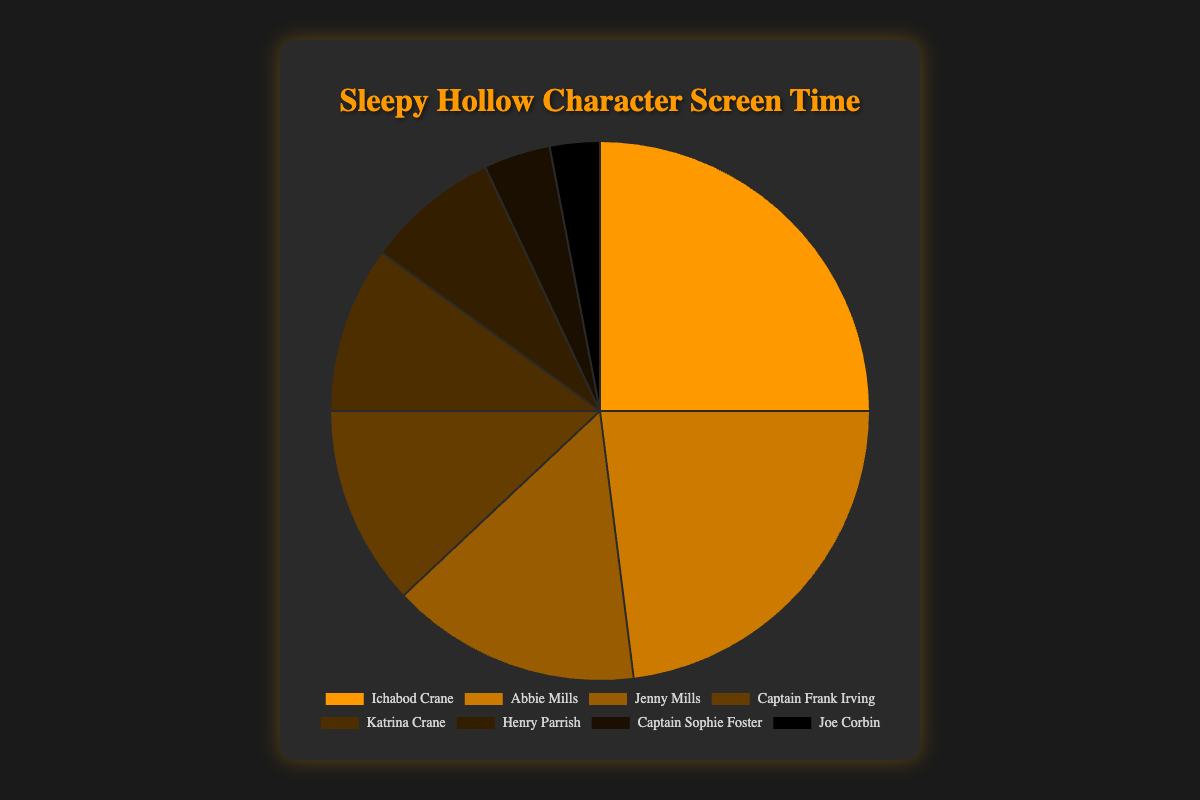Which character has the highest percentage of screen time? Ichabod Crane has the highest screen time percentage. By looking at the pie chart, Crane's segment is the largest, corresponding to 25%.
Answer: Ichabod Crane Compare the screen time percentages of Abbie Mills and Jenny Mills. Who has more and by how much? Abbie Mills has a 23% screen time percentage, while Jenny Mills has 15%. The difference is 23% - 15% = 8%.
Answer: Abbie Mills by 8% What is the combined screen time percentage of Captain Frank Irving, Katrina Crane, and Henry Parrish? Sum of screen time percentages of Captain Frank Irving (12%), Katrina Crane (10%), and Henry Parrish (8%) gives 12% + 10% + 8% = 30%.
Answer: 30% Which character has the least screen time percentage, and what is the percentage? Joe Corbin has the least screen time percentage, shown by the smallest segment on the pie chart at 3%.
Answer: Joe Corbin, 3% How does Ichabod Crane's screen time compare to the combined screen time of Captain Sophie Foster and Joe Corbin? Ichabod Crane's screen time is 25%, while the combined screen time of Captain Sophie Foster (4%) and Joe Corbin (3%) is 4% + 3% = 7%. Ichabod Crane’s screen time is significantly higher (25% > 7%).
Answer: Ichabod Crane has more What's the average screen time percentage of the characters with a percentage higher than 10%? Characters with more than 10% screen time are Ichabod Crane (25%), Abbie Mills (23%), Jenny Mills (15%), and Captain Frank Irving (12%). Average = (25 + 23 + 15 + 12) / 4 = 75 / 4 = 18.75%
Answer: 18.75% Which characters’ screen time percentages are represented by shades of brown and which shade did each represent? There are five shades of brown, representing different characters: #ff9900 (brightest brown) for Ichabod Crane, #cc7a00 for Abbie Mills, #995c00 for Jenny Mills, #663d00 for Captain Frank Irving, and #4d2e00 for Katrina Crane.
Answer: Ichabod Crane, Abbie Mills, Jenny Mills, Captain Frank Irving, Katrina Crane 